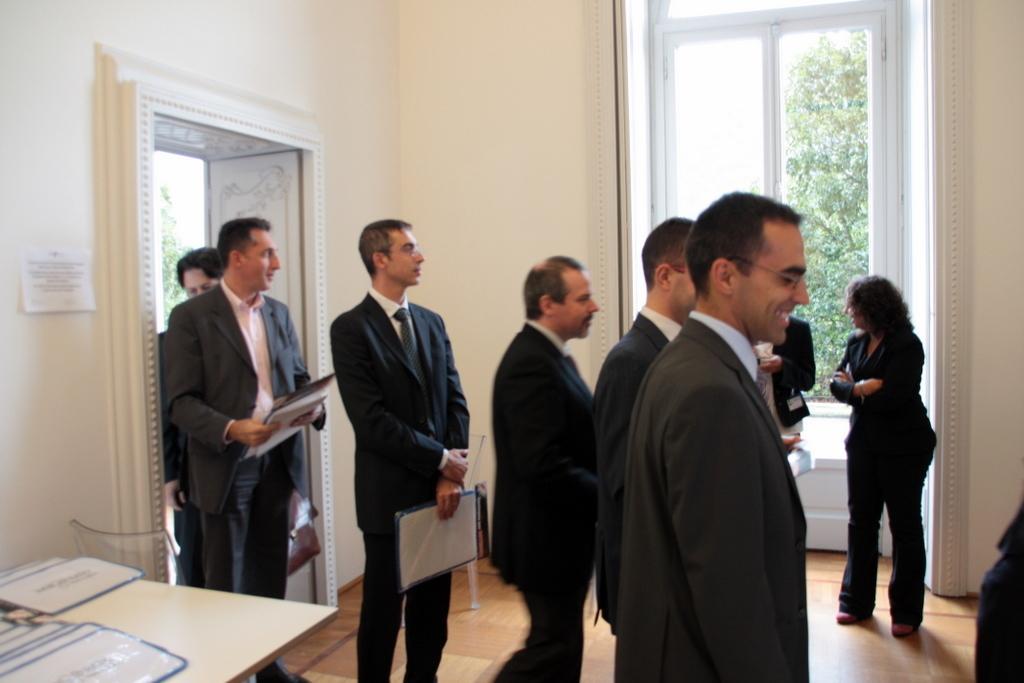In one or two sentences, can you explain what this image depicts? In this image there are few people in which some of them are holding some files, there are a few files on the desk, a poster attached to the wall and a window, outside the window there is a tree. 